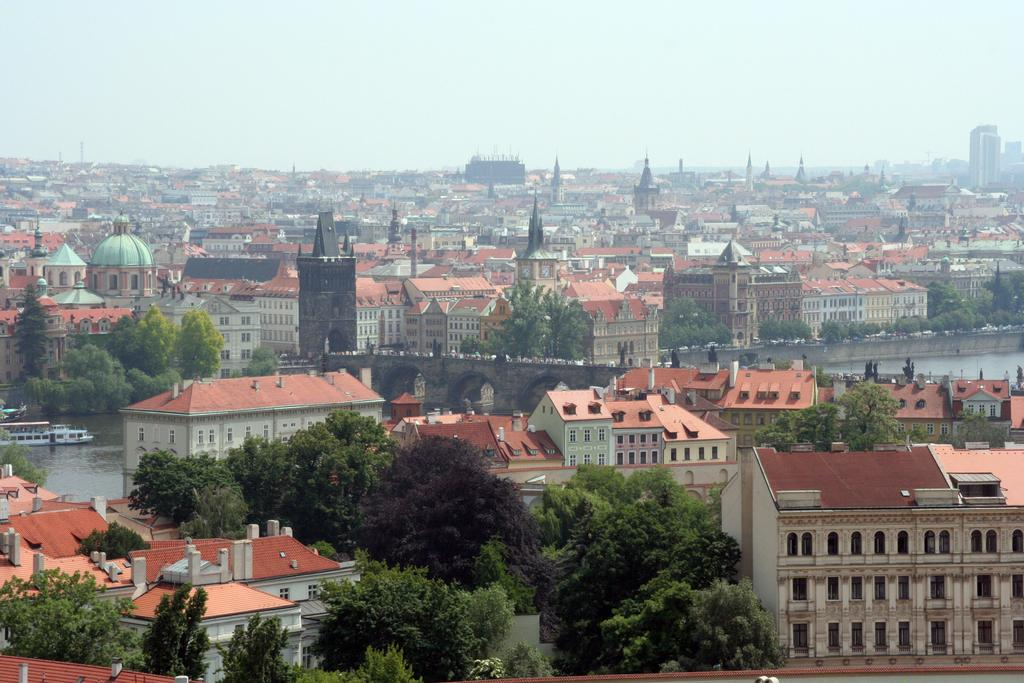What type of structures can be seen in the image? There are buildings in the image. What other natural elements are present in the image? There are trees in the image. What connects the two sides of the image? There is a bridge in the image. What is visible at the top of the image? The sky is visible at the top of the image. What can be seen on the left side of the image? There is a boat on the water on the left side of the image. What type of apparel is the office wearing in the image? There is no office present in the image, and therefore no apparel can be associated with it. What type of work is being done in the image? There is no indication of work being done in the image, as it primarily features natural and man-made structures. 